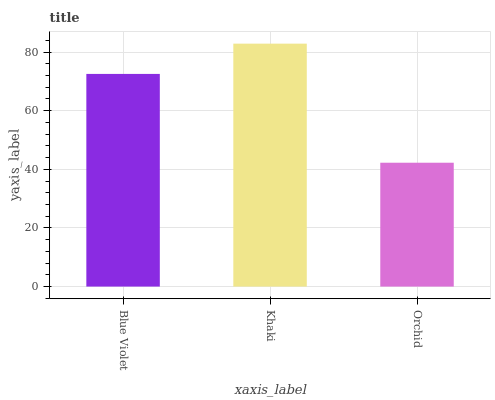Is Orchid the minimum?
Answer yes or no. Yes. Is Khaki the maximum?
Answer yes or no. Yes. Is Khaki the minimum?
Answer yes or no. No. Is Orchid the maximum?
Answer yes or no. No. Is Khaki greater than Orchid?
Answer yes or no. Yes. Is Orchid less than Khaki?
Answer yes or no. Yes. Is Orchid greater than Khaki?
Answer yes or no. No. Is Khaki less than Orchid?
Answer yes or no. No. Is Blue Violet the high median?
Answer yes or no. Yes. Is Blue Violet the low median?
Answer yes or no. Yes. Is Khaki the high median?
Answer yes or no. No. Is Orchid the low median?
Answer yes or no. No. 